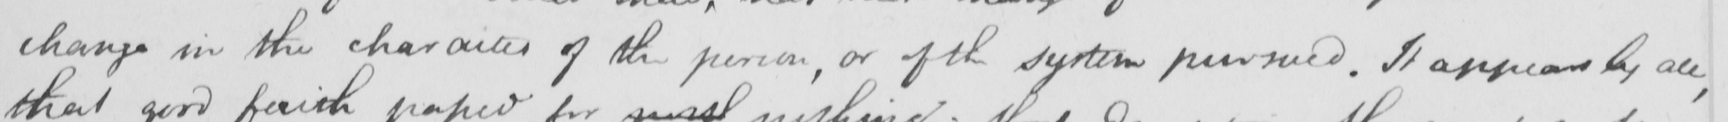Transcribe the text shown in this historical manuscript line. change in the character of the person , or of the system pursued . It appears by all , 